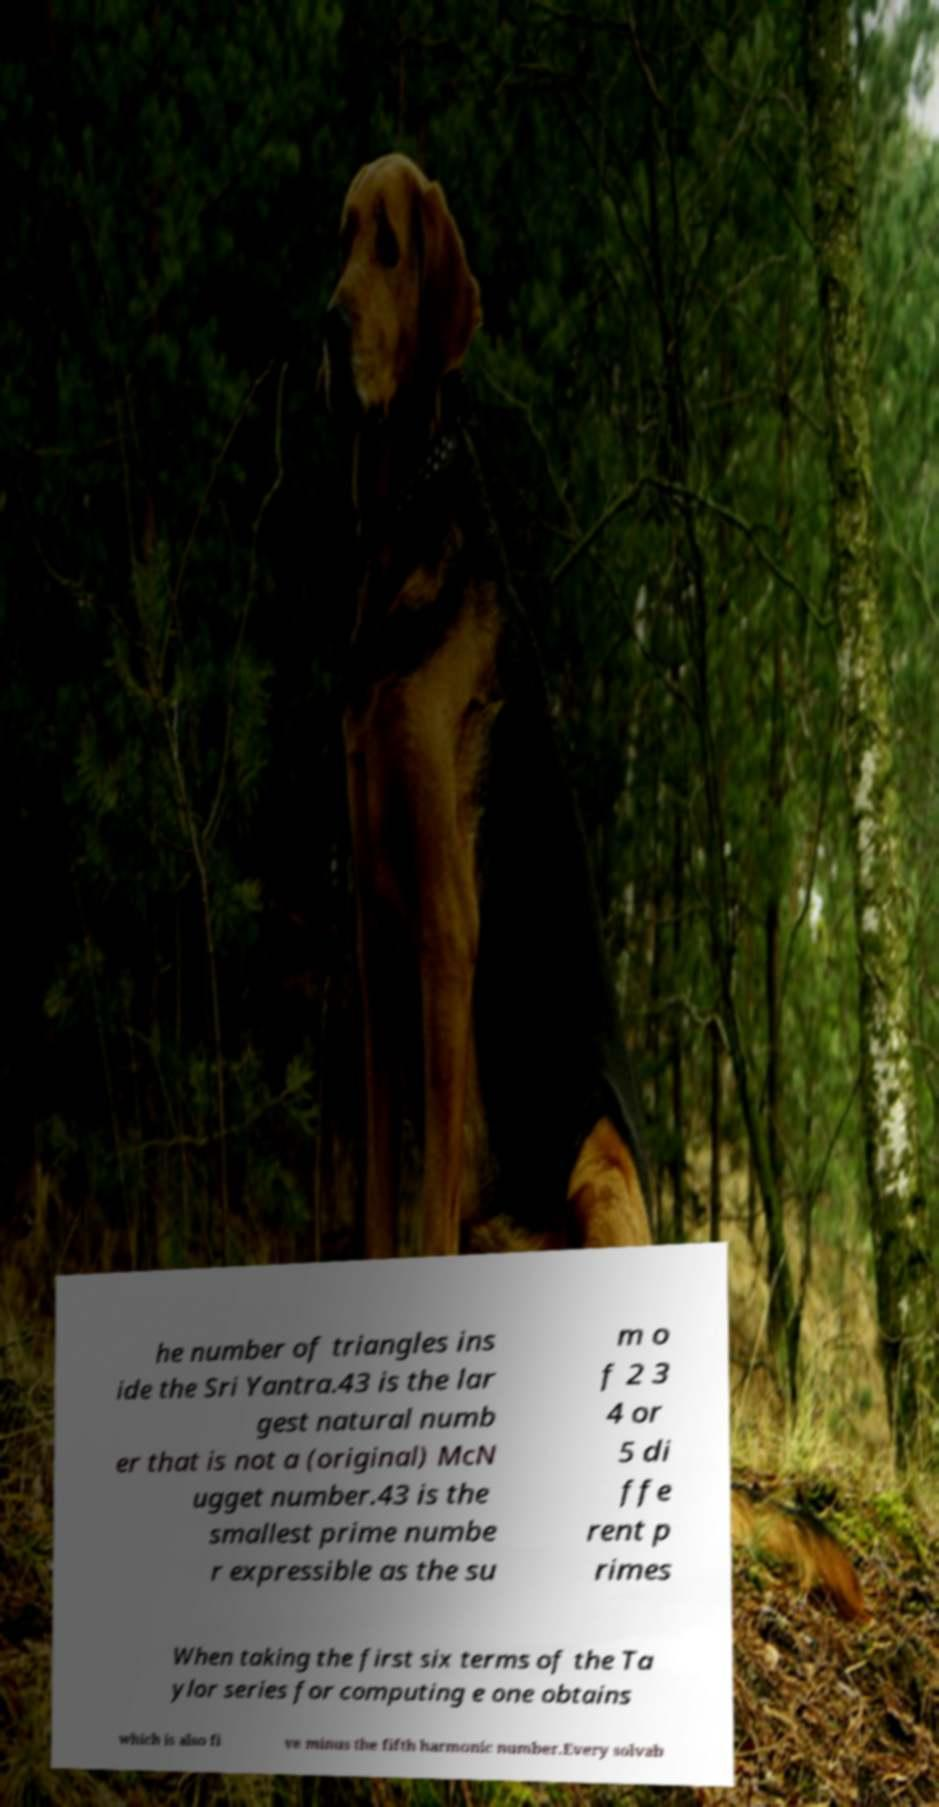Please identify and transcribe the text found in this image. he number of triangles ins ide the Sri Yantra.43 is the lar gest natural numb er that is not a (original) McN ugget number.43 is the smallest prime numbe r expressible as the su m o f 2 3 4 or 5 di ffe rent p rimes When taking the first six terms of the Ta ylor series for computing e one obtains which is also fi ve minus the fifth harmonic number.Every solvab 